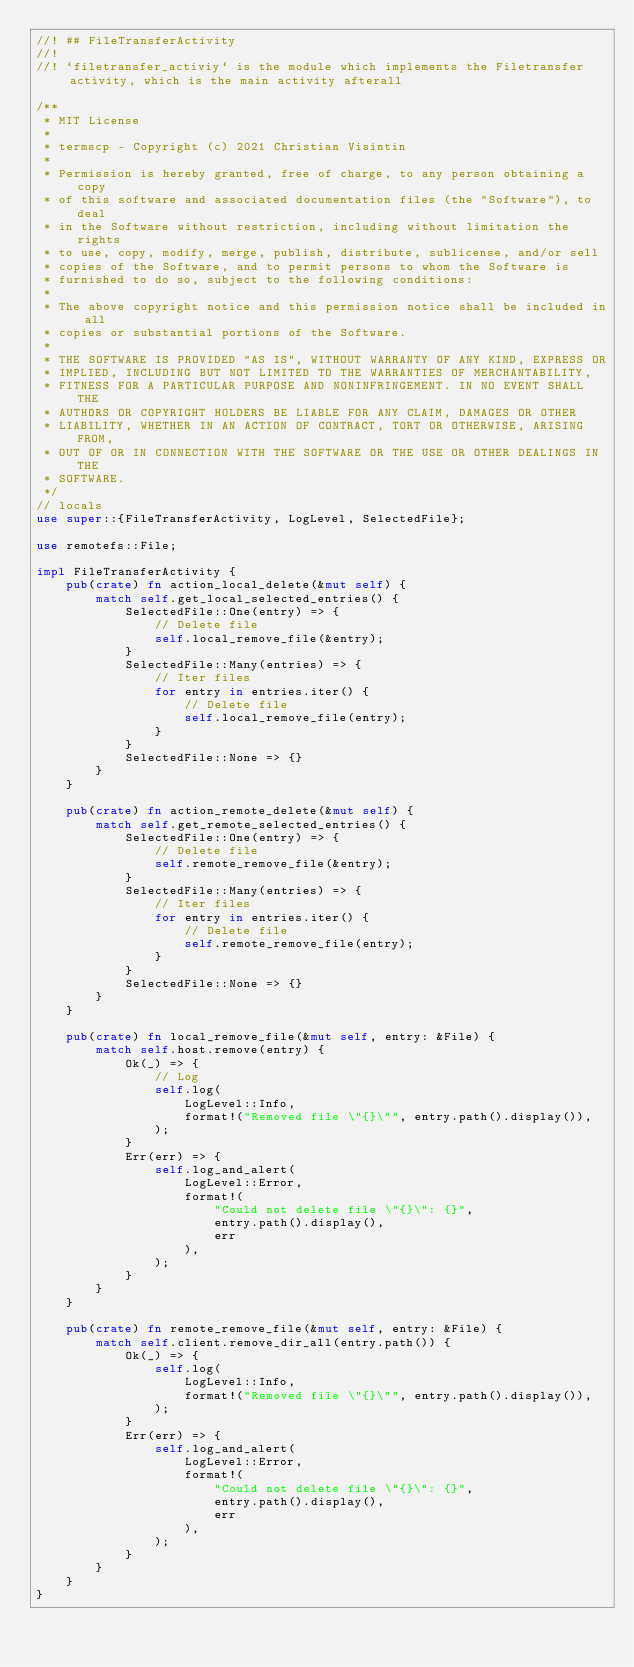Convert code to text. <code><loc_0><loc_0><loc_500><loc_500><_Rust_>//! ## FileTransferActivity
//!
//! `filetransfer_activiy` is the module which implements the Filetransfer activity, which is the main activity afterall

/**
 * MIT License
 *
 * termscp - Copyright (c) 2021 Christian Visintin
 *
 * Permission is hereby granted, free of charge, to any person obtaining a copy
 * of this software and associated documentation files (the "Software"), to deal
 * in the Software without restriction, including without limitation the rights
 * to use, copy, modify, merge, publish, distribute, sublicense, and/or sell
 * copies of the Software, and to permit persons to whom the Software is
 * furnished to do so, subject to the following conditions:
 *
 * The above copyright notice and this permission notice shall be included in all
 * copies or substantial portions of the Software.
 *
 * THE SOFTWARE IS PROVIDED "AS IS", WITHOUT WARRANTY OF ANY KIND, EXPRESS OR
 * IMPLIED, INCLUDING BUT NOT LIMITED TO THE WARRANTIES OF MERCHANTABILITY,
 * FITNESS FOR A PARTICULAR PURPOSE AND NONINFRINGEMENT. IN NO EVENT SHALL THE
 * AUTHORS OR COPYRIGHT HOLDERS BE LIABLE FOR ANY CLAIM, DAMAGES OR OTHER
 * LIABILITY, WHETHER IN AN ACTION OF CONTRACT, TORT OR OTHERWISE, ARISING FROM,
 * OUT OF OR IN CONNECTION WITH THE SOFTWARE OR THE USE OR OTHER DEALINGS IN THE
 * SOFTWARE.
 */
// locals
use super::{FileTransferActivity, LogLevel, SelectedFile};

use remotefs::File;

impl FileTransferActivity {
    pub(crate) fn action_local_delete(&mut self) {
        match self.get_local_selected_entries() {
            SelectedFile::One(entry) => {
                // Delete file
                self.local_remove_file(&entry);
            }
            SelectedFile::Many(entries) => {
                // Iter files
                for entry in entries.iter() {
                    // Delete file
                    self.local_remove_file(entry);
                }
            }
            SelectedFile::None => {}
        }
    }

    pub(crate) fn action_remote_delete(&mut self) {
        match self.get_remote_selected_entries() {
            SelectedFile::One(entry) => {
                // Delete file
                self.remote_remove_file(&entry);
            }
            SelectedFile::Many(entries) => {
                // Iter files
                for entry in entries.iter() {
                    // Delete file
                    self.remote_remove_file(entry);
                }
            }
            SelectedFile::None => {}
        }
    }

    pub(crate) fn local_remove_file(&mut self, entry: &File) {
        match self.host.remove(entry) {
            Ok(_) => {
                // Log
                self.log(
                    LogLevel::Info,
                    format!("Removed file \"{}\"", entry.path().display()),
                );
            }
            Err(err) => {
                self.log_and_alert(
                    LogLevel::Error,
                    format!(
                        "Could not delete file \"{}\": {}",
                        entry.path().display(),
                        err
                    ),
                );
            }
        }
    }

    pub(crate) fn remote_remove_file(&mut self, entry: &File) {
        match self.client.remove_dir_all(entry.path()) {
            Ok(_) => {
                self.log(
                    LogLevel::Info,
                    format!("Removed file \"{}\"", entry.path().display()),
                );
            }
            Err(err) => {
                self.log_and_alert(
                    LogLevel::Error,
                    format!(
                        "Could not delete file \"{}\": {}",
                        entry.path().display(),
                        err
                    ),
                );
            }
        }
    }
}
</code> 